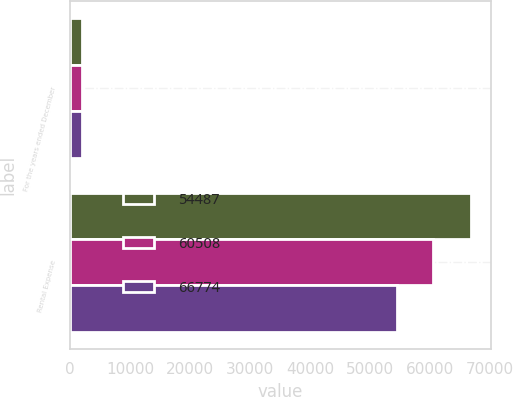Convert chart. <chart><loc_0><loc_0><loc_500><loc_500><stacked_bar_chart><ecel><fcel>For the years ended December<fcel>Rental Expense<nl><fcel>54487<fcel>2016<fcel>66774<nl><fcel>60508<fcel>2015<fcel>60508<nl><fcel>66774<fcel>2014<fcel>54487<nl></chart> 